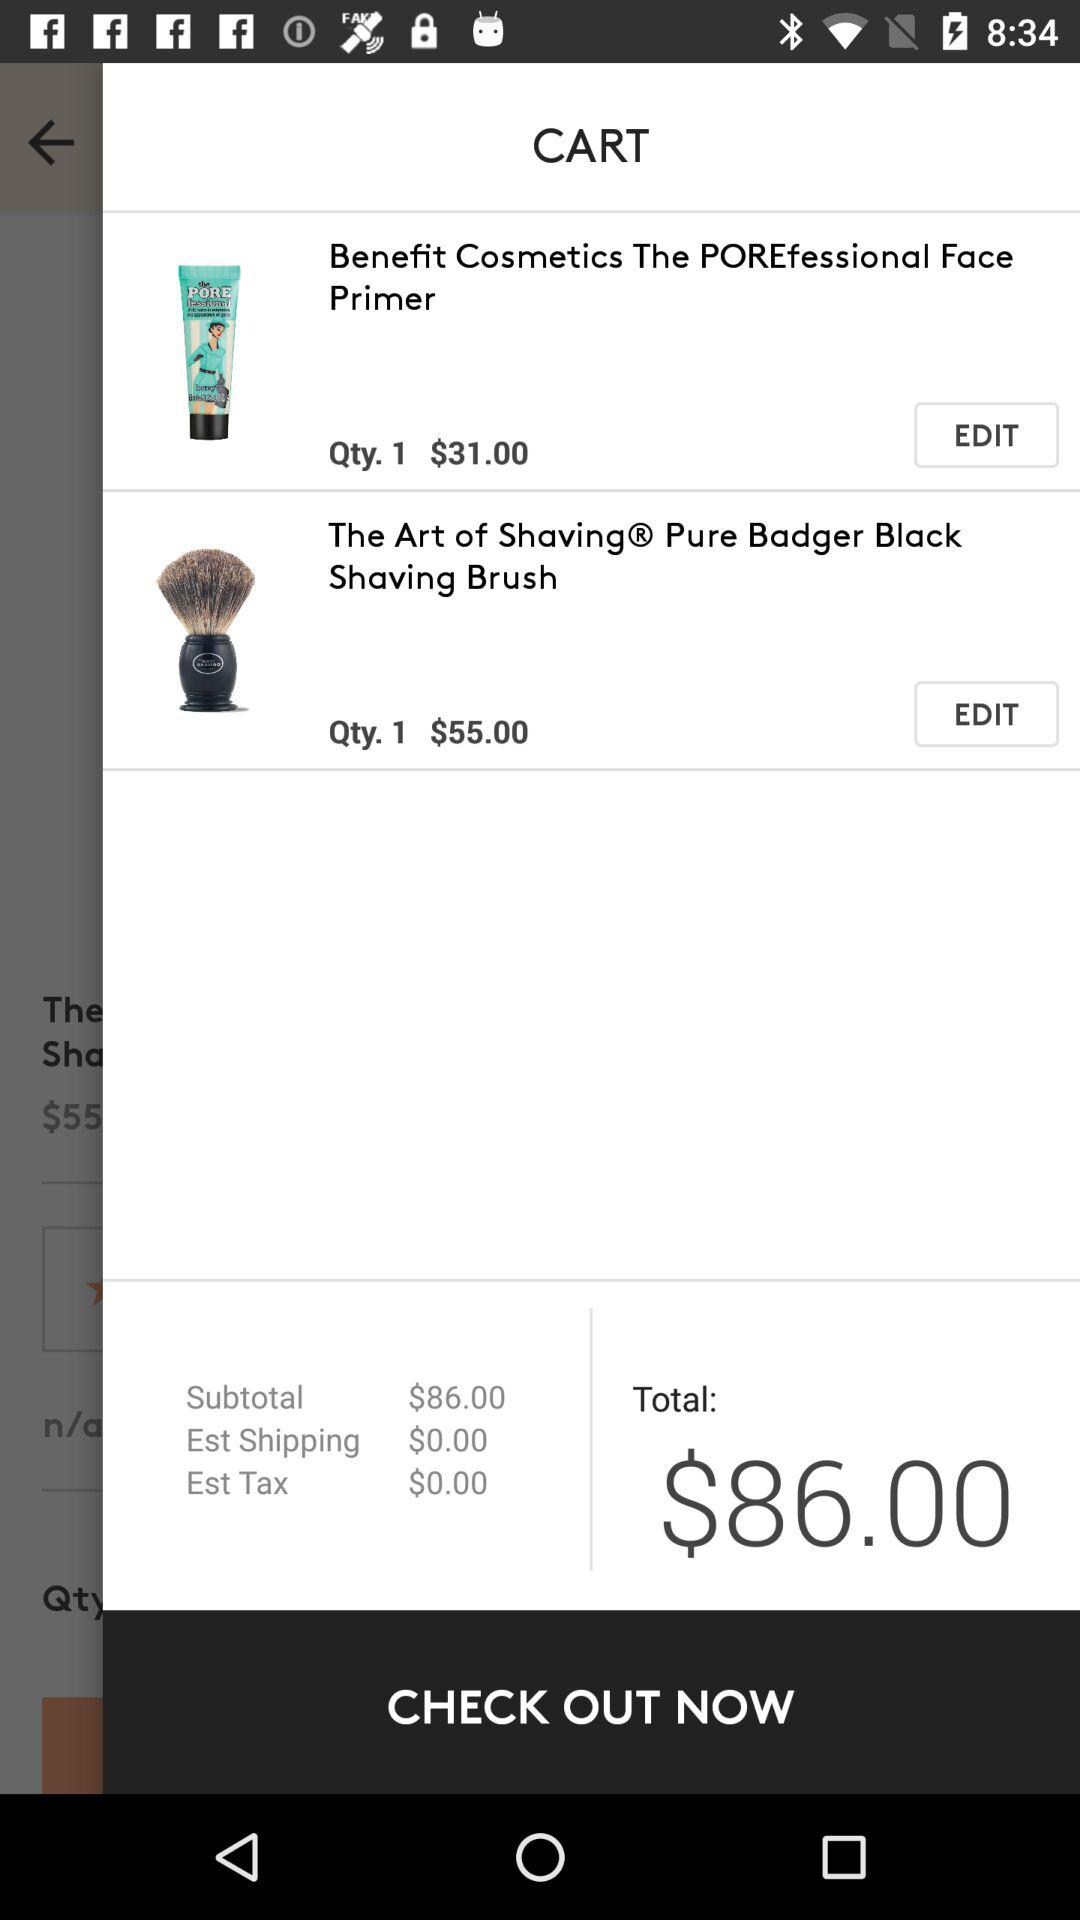What are the shipping charges? The shipping charges are $0. 